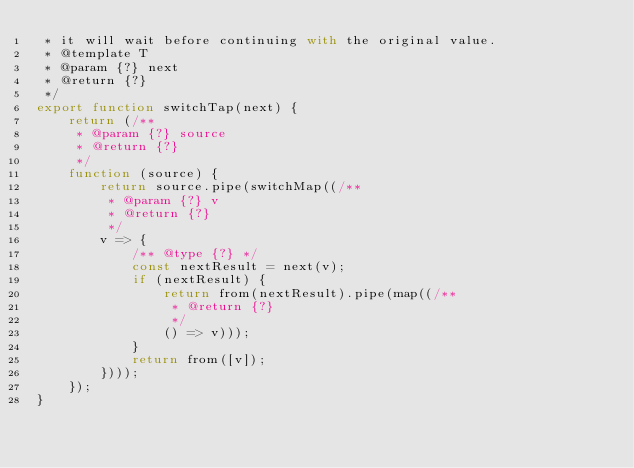Convert code to text. <code><loc_0><loc_0><loc_500><loc_500><_JavaScript_> * it will wait before continuing with the original value.
 * @template T
 * @param {?} next
 * @return {?}
 */
export function switchTap(next) {
    return (/**
     * @param {?} source
     * @return {?}
     */
    function (source) {
        return source.pipe(switchMap((/**
         * @param {?} v
         * @return {?}
         */
        v => {
            /** @type {?} */
            const nextResult = next(v);
            if (nextResult) {
                return from(nextResult).pipe(map((/**
                 * @return {?}
                 */
                () => v)));
            }
            return from([v]);
        })));
    });
}</code> 